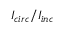<formula> <loc_0><loc_0><loc_500><loc_500>I _ { c i r c } / I _ { i n c }</formula> 